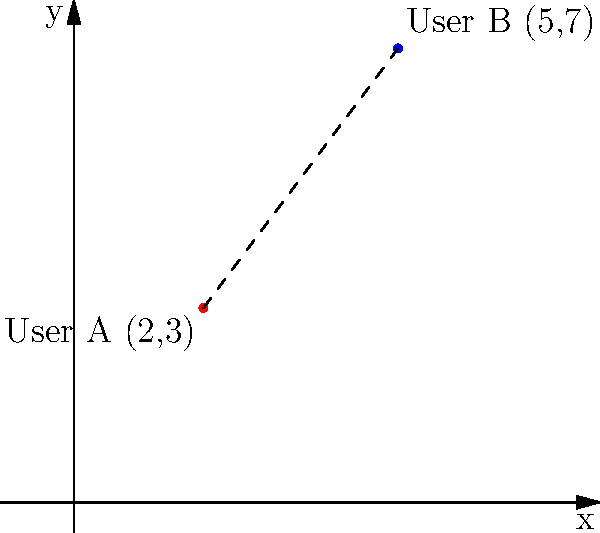On a social network platform, users' locations are represented on a coordinate plane. User A is at position (2,3) and User B is at position (5,7). Calculate the distance between these two users using the distance formula. Round your answer to two decimal places. To solve this problem, we'll use the distance formula derived from the Pythagorean theorem:

$$d = \sqrt{(x_2 - x_1)^2 + (y_2 - y_1)^2}$$

Where $(x_1, y_1)$ is the coordinate of User A and $(x_2, y_2)$ is the coordinate of User B.

Step 1: Identify the coordinates
User A: $(x_1, y_1) = (2, 3)$
User B: $(x_2, y_2) = (5, 7)$

Step 2: Plug the values into the distance formula
$$d = \sqrt{(5 - 2)^2 + (7 - 3)^2}$$

Step 3: Simplify the expressions inside the parentheses
$$d = \sqrt{3^2 + 4^2}$$

Step 4: Calculate the squares
$$d = \sqrt{9 + 16}$$

Step 5: Add the values under the square root
$$d = \sqrt{25}$$

Step 6: Calculate the square root
$$d = 5$$

The exact distance between User A and User B is 5 units.

Since the question asks for the answer rounded to two decimal places, our final answer is 5.00.
Answer: 5.00 units 